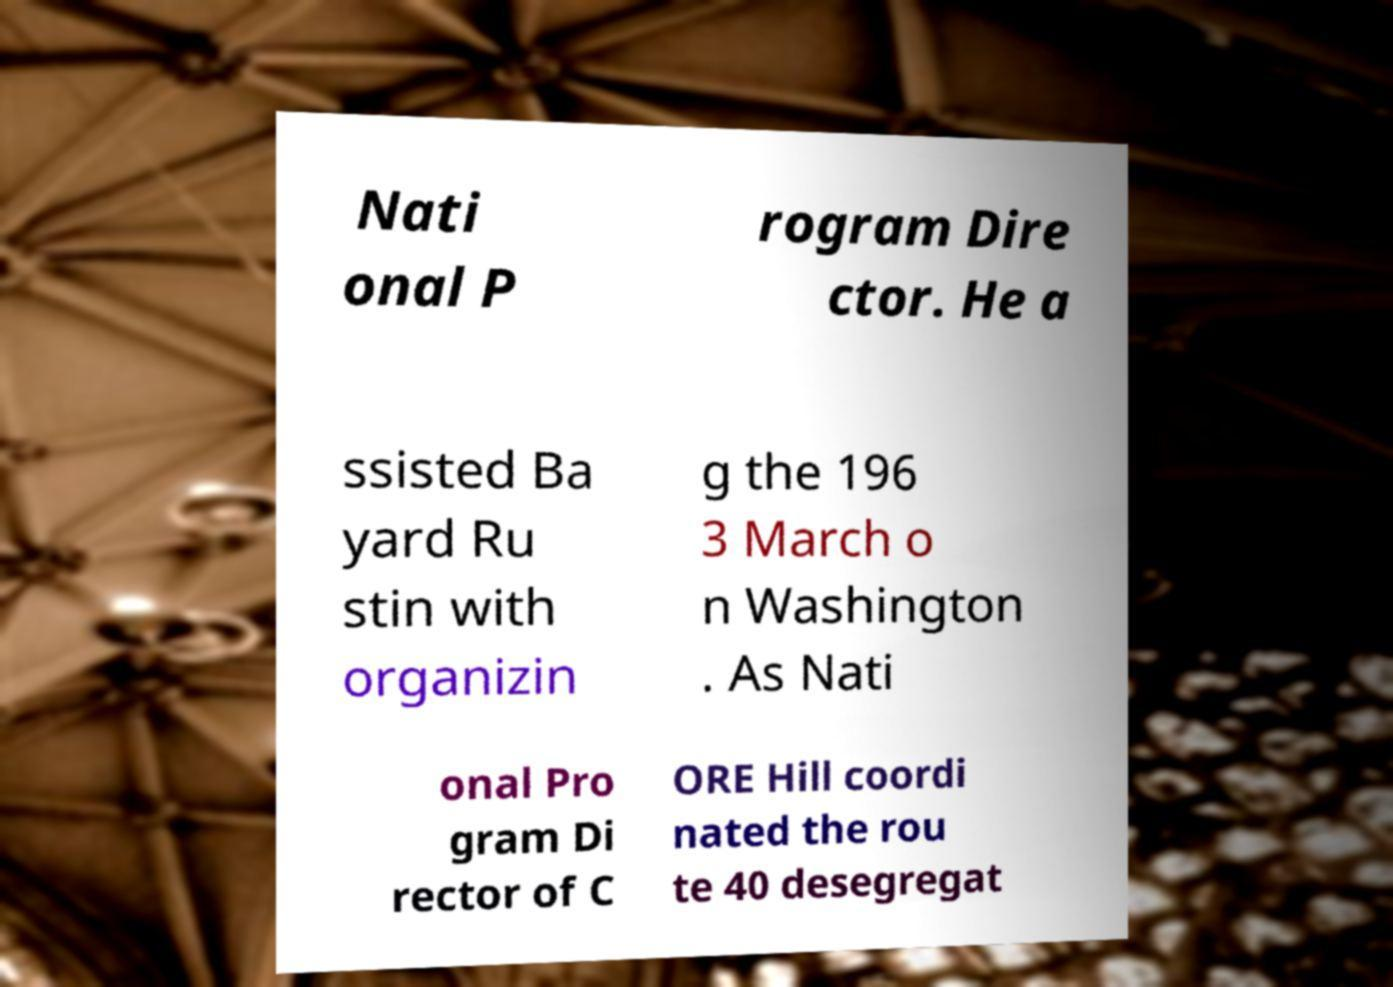For documentation purposes, I need the text within this image transcribed. Could you provide that? Nati onal P rogram Dire ctor. He a ssisted Ba yard Ru stin with organizin g the 196 3 March o n Washington . As Nati onal Pro gram Di rector of C ORE Hill coordi nated the rou te 40 desegregat 